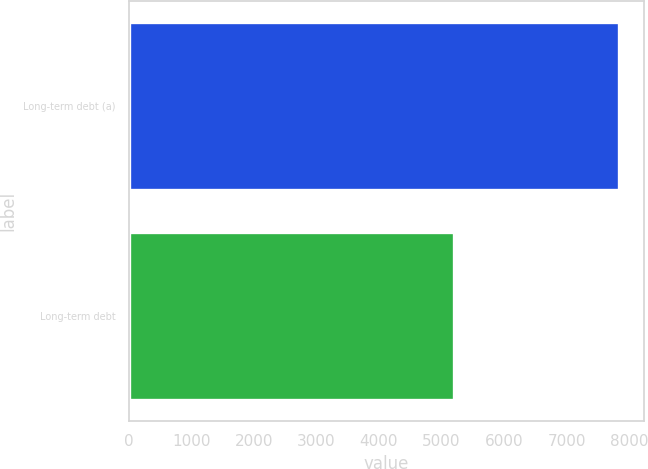Convert chart to OTSL. <chart><loc_0><loc_0><loc_500><loc_500><bar_chart><fcel>Long-term debt (a)<fcel>Long-term debt<nl><fcel>7838<fcel>5196<nl></chart> 